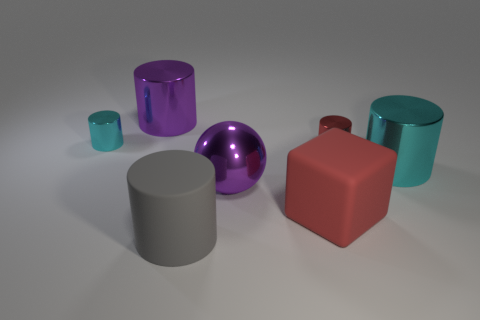What shape is the cyan metal object that is behind the cyan metallic cylinder in front of the red metallic cylinder?
Give a very brief answer. Cylinder. There is a cyan object that is to the left of the red thing that is in front of the tiny red metallic thing; what size is it?
Offer a very short reply. Small. What color is the small metal cylinder left of the red block?
Provide a short and direct response. Cyan. What size is the purple ball that is the same material as the big cyan cylinder?
Provide a succinct answer. Large. What number of tiny red things have the same shape as the big gray matte thing?
Your answer should be compact. 1. What material is the cylinder that is the same size as the red metal object?
Keep it short and to the point. Metal. Are there any small cyan cylinders that have the same material as the large purple sphere?
Make the answer very short. Yes. There is a large thing that is both right of the ball and in front of the large cyan metal object; what is its color?
Offer a terse response. Red. What number of other things are there of the same color as the block?
Your response must be concise. 1. There is a big cylinder that is behind the small metal object left of the purple thing that is left of the purple metallic ball; what is it made of?
Your answer should be compact. Metal. 